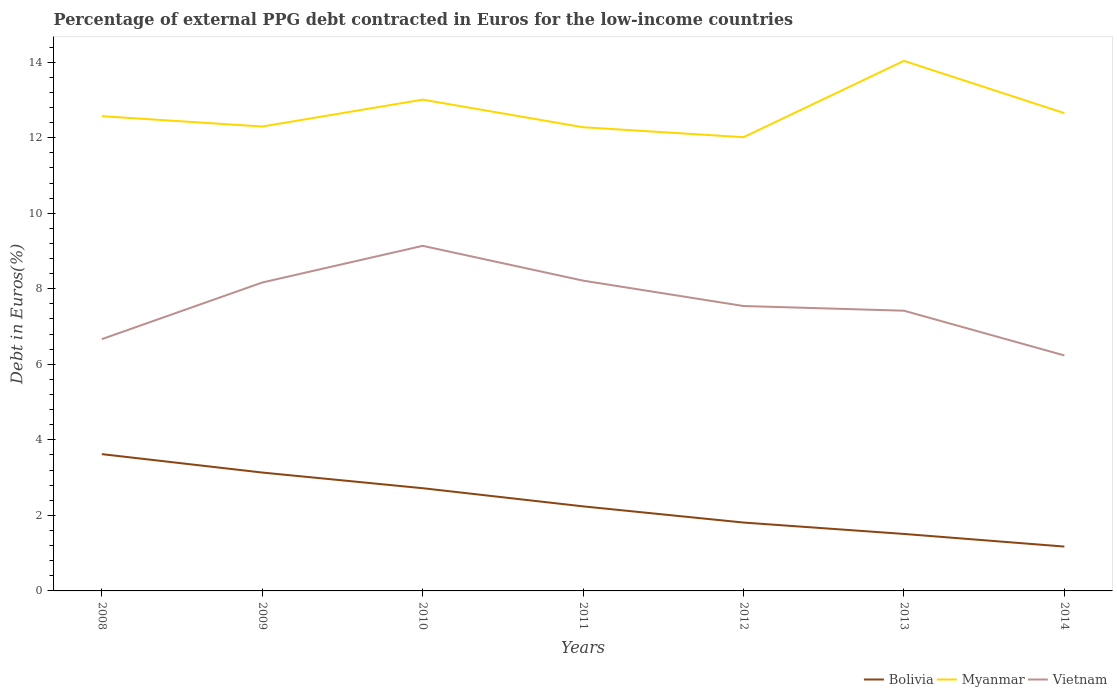Does the line corresponding to Bolivia intersect with the line corresponding to Vietnam?
Your answer should be compact. No. Is the number of lines equal to the number of legend labels?
Offer a very short reply. Yes. Across all years, what is the maximum percentage of external PPG debt contracted in Euros in Myanmar?
Ensure brevity in your answer.  12.01. In which year was the percentage of external PPG debt contracted in Euros in Myanmar maximum?
Give a very brief answer. 2012. What is the total percentage of external PPG debt contracted in Euros in Bolivia in the graph?
Make the answer very short. 1.63. What is the difference between the highest and the second highest percentage of external PPG debt contracted in Euros in Vietnam?
Give a very brief answer. 2.9. What is the difference between the highest and the lowest percentage of external PPG debt contracted in Euros in Myanmar?
Offer a very short reply. 2. Is the percentage of external PPG debt contracted in Euros in Myanmar strictly greater than the percentage of external PPG debt contracted in Euros in Bolivia over the years?
Ensure brevity in your answer.  No. How many years are there in the graph?
Give a very brief answer. 7. What is the difference between two consecutive major ticks on the Y-axis?
Make the answer very short. 2. Are the values on the major ticks of Y-axis written in scientific E-notation?
Ensure brevity in your answer.  No. Does the graph contain any zero values?
Your response must be concise. No. Does the graph contain grids?
Your answer should be very brief. No. Where does the legend appear in the graph?
Your answer should be compact. Bottom right. How many legend labels are there?
Provide a succinct answer. 3. How are the legend labels stacked?
Give a very brief answer. Horizontal. What is the title of the graph?
Keep it short and to the point. Percentage of external PPG debt contracted in Euros for the low-income countries. Does "Kenya" appear as one of the legend labels in the graph?
Ensure brevity in your answer.  No. What is the label or title of the X-axis?
Your answer should be compact. Years. What is the label or title of the Y-axis?
Make the answer very short. Debt in Euros(%). What is the Debt in Euros(%) of Bolivia in 2008?
Ensure brevity in your answer.  3.62. What is the Debt in Euros(%) of Myanmar in 2008?
Your response must be concise. 12.57. What is the Debt in Euros(%) in Vietnam in 2008?
Keep it short and to the point. 6.67. What is the Debt in Euros(%) of Bolivia in 2009?
Provide a short and direct response. 3.13. What is the Debt in Euros(%) in Myanmar in 2009?
Provide a succinct answer. 12.3. What is the Debt in Euros(%) in Vietnam in 2009?
Offer a terse response. 8.17. What is the Debt in Euros(%) in Bolivia in 2010?
Your response must be concise. 2.72. What is the Debt in Euros(%) of Myanmar in 2010?
Make the answer very short. 13.01. What is the Debt in Euros(%) of Vietnam in 2010?
Offer a terse response. 9.14. What is the Debt in Euros(%) in Bolivia in 2011?
Your answer should be very brief. 2.24. What is the Debt in Euros(%) of Myanmar in 2011?
Offer a very short reply. 12.28. What is the Debt in Euros(%) in Vietnam in 2011?
Give a very brief answer. 8.22. What is the Debt in Euros(%) of Bolivia in 2012?
Your response must be concise. 1.81. What is the Debt in Euros(%) in Myanmar in 2012?
Make the answer very short. 12.01. What is the Debt in Euros(%) in Vietnam in 2012?
Offer a terse response. 7.54. What is the Debt in Euros(%) of Bolivia in 2013?
Give a very brief answer. 1.51. What is the Debt in Euros(%) of Myanmar in 2013?
Your response must be concise. 14.03. What is the Debt in Euros(%) of Vietnam in 2013?
Make the answer very short. 7.42. What is the Debt in Euros(%) of Bolivia in 2014?
Your answer should be very brief. 1.17. What is the Debt in Euros(%) in Myanmar in 2014?
Provide a short and direct response. 12.65. What is the Debt in Euros(%) in Vietnam in 2014?
Ensure brevity in your answer.  6.23. Across all years, what is the maximum Debt in Euros(%) of Bolivia?
Provide a succinct answer. 3.62. Across all years, what is the maximum Debt in Euros(%) in Myanmar?
Keep it short and to the point. 14.03. Across all years, what is the maximum Debt in Euros(%) in Vietnam?
Make the answer very short. 9.14. Across all years, what is the minimum Debt in Euros(%) of Bolivia?
Make the answer very short. 1.17. Across all years, what is the minimum Debt in Euros(%) of Myanmar?
Provide a short and direct response. 12.01. Across all years, what is the minimum Debt in Euros(%) of Vietnam?
Provide a succinct answer. 6.23. What is the total Debt in Euros(%) in Bolivia in the graph?
Provide a short and direct response. 16.21. What is the total Debt in Euros(%) of Myanmar in the graph?
Provide a succinct answer. 88.85. What is the total Debt in Euros(%) of Vietnam in the graph?
Your answer should be compact. 53.38. What is the difference between the Debt in Euros(%) of Bolivia in 2008 and that in 2009?
Provide a short and direct response. 0.49. What is the difference between the Debt in Euros(%) of Myanmar in 2008 and that in 2009?
Provide a succinct answer. 0.27. What is the difference between the Debt in Euros(%) in Vietnam in 2008 and that in 2009?
Your answer should be very brief. -1.5. What is the difference between the Debt in Euros(%) in Bolivia in 2008 and that in 2010?
Offer a terse response. 0.9. What is the difference between the Debt in Euros(%) of Myanmar in 2008 and that in 2010?
Offer a very short reply. -0.44. What is the difference between the Debt in Euros(%) of Vietnam in 2008 and that in 2010?
Offer a terse response. -2.47. What is the difference between the Debt in Euros(%) in Bolivia in 2008 and that in 2011?
Ensure brevity in your answer.  1.38. What is the difference between the Debt in Euros(%) in Myanmar in 2008 and that in 2011?
Offer a very short reply. 0.29. What is the difference between the Debt in Euros(%) of Vietnam in 2008 and that in 2011?
Make the answer very short. -1.55. What is the difference between the Debt in Euros(%) in Bolivia in 2008 and that in 2012?
Your answer should be compact. 1.81. What is the difference between the Debt in Euros(%) in Myanmar in 2008 and that in 2012?
Offer a very short reply. 0.56. What is the difference between the Debt in Euros(%) in Vietnam in 2008 and that in 2012?
Your response must be concise. -0.88. What is the difference between the Debt in Euros(%) in Bolivia in 2008 and that in 2013?
Your response must be concise. 2.11. What is the difference between the Debt in Euros(%) of Myanmar in 2008 and that in 2013?
Provide a short and direct response. -1.46. What is the difference between the Debt in Euros(%) in Vietnam in 2008 and that in 2013?
Keep it short and to the point. -0.75. What is the difference between the Debt in Euros(%) of Bolivia in 2008 and that in 2014?
Give a very brief answer. 2.45. What is the difference between the Debt in Euros(%) of Myanmar in 2008 and that in 2014?
Give a very brief answer. -0.08. What is the difference between the Debt in Euros(%) of Vietnam in 2008 and that in 2014?
Your answer should be very brief. 0.43. What is the difference between the Debt in Euros(%) in Bolivia in 2009 and that in 2010?
Make the answer very short. 0.41. What is the difference between the Debt in Euros(%) of Myanmar in 2009 and that in 2010?
Offer a very short reply. -0.71. What is the difference between the Debt in Euros(%) of Vietnam in 2009 and that in 2010?
Give a very brief answer. -0.97. What is the difference between the Debt in Euros(%) in Bolivia in 2009 and that in 2011?
Ensure brevity in your answer.  0.9. What is the difference between the Debt in Euros(%) of Myanmar in 2009 and that in 2011?
Make the answer very short. 0.02. What is the difference between the Debt in Euros(%) in Vietnam in 2009 and that in 2011?
Your answer should be compact. -0.05. What is the difference between the Debt in Euros(%) of Bolivia in 2009 and that in 2012?
Your answer should be compact. 1.32. What is the difference between the Debt in Euros(%) of Myanmar in 2009 and that in 2012?
Offer a terse response. 0.28. What is the difference between the Debt in Euros(%) of Vietnam in 2009 and that in 2012?
Offer a very short reply. 0.62. What is the difference between the Debt in Euros(%) of Bolivia in 2009 and that in 2013?
Ensure brevity in your answer.  1.63. What is the difference between the Debt in Euros(%) in Myanmar in 2009 and that in 2013?
Your answer should be compact. -1.74. What is the difference between the Debt in Euros(%) in Vietnam in 2009 and that in 2013?
Give a very brief answer. 0.75. What is the difference between the Debt in Euros(%) of Bolivia in 2009 and that in 2014?
Ensure brevity in your answer.  1.96. What is the difference between the Debt in Euros(%) of Myanmar in 2009 and that in 2014?
Give a very brief answer. -0.35. What is the difference between the Debt in Euros(%) in Vietnam in 2009 and that in 2014?
Ensure brevity in your answer.  1.93. What is the difference between the Debt in Euros(%) in Bolivia in 2010 and that in 2011?
Your response must be concise. 0.48. What is the difference between the Debt in Euros(%) of Myanmar in 2010 and that in 2011?
Keep it short and to the point. 0.73. What is the difference between the Debt in Euros(%) of Vietnam in 2010 and that in 2011?
Offer a very short reply. 0.92. What is the difference between the Debt in Euros(%) of Bolivia in 2010 and that in 2012?
Offer a very short reply. 0.91. What is the difference between the Debt in Euros(%) in Myanmar in 2010 and that in 2012?
Make the answer very short. 0.99. What is the difference between the Debt in Euros(%) in Vietnam in 2010 and that in 2012?
Ensure brevity in your answer.  1.59. What is the difference between the Debt in Euros(%) in Bolivia in 2010 and that in 2013?
Offer a terse response. 1.21. What is the difference between the Debt in Euros(%) of Myanmar in 2010 and that in 2013?
Your answer should be compact. -1.03. What is the difference between the Debt in Euros(%) of Vietnam in 2010 and that in 2013?
Your answer should be very brief. 1.72. What is the difference between the Debt in Euros(%) of Bolivia in 2010 and that in 2014?
Provide a succinct answer. 1.54. What is the difference between the Debt in Euros(%) of Myanmar in 2010 and that in 2014?
Offer a very short reply. 0.36. What is the difference between the Debt in Euros(%) in Vietnam in 2010 and that in 2014?
Your response must be concise. 2.9. What is the difference between the Debt in Euros(%) of Bolivia in 2011 and that in 2012?
Keep it short and to the point. 0.43. What is the difference between the Debt in Euros(%) of Myanmar in 2011 and that in 2012?
Provide a short and direct response. 0.26. What is the difference between the Debt in Euros(%) in Vietnam in 2011 and that in 2012?
Ensure brevity in your answer.  0.67. What is the difference between the Debt in Euros(%) of Bolivia in 2011 and that in 2013?
Provide a succinct answer. 0.73. What is the difference between the Debt in Euros(%) in Myanmar in 2011 and that in 2013?
Your answer should be compact. -1.76. What is the difference between the Debt in Euros(%) in Vietnam in 2011 and that in 2013?
Make the answer very short. 0.8. What is the difference between the Debt in Euros(%) of Bolivia in 2011 and that in 2014?
Your answer should be compact. 1.06. What is the difference between the Debt in Euros(%) of Myanmar in 2011 and that in 2014?
Make the answer very short. -0.37. What is the difference between the Debt in Euros(%) of Vietnam in 2011 and that in 2014?
Make the answer very short. 1.98. What is the difference between the Debt in Euros(%) in Bolivia in 2012 and that in 2013?
Your answer should be compact. 0.3. What is the difference between the Debt in Euros(%) in Myanmar in 2012 and that in 2013?
Offer a very short reply. -2.02. What is the difference between the Debt in Euros(%) of Vietnam in 2012 and that in 2013?
Keep it short and to the point. 0.12. What is the difference between the Debt in Euros(%) of Bolivia in 2012 and that in 2014?
Offer a terse response. 0.64. What is the difference between the Debt in Euros(%) of Myanmar in 2012 and that in 2014?
Offer a terse response. -0.64. What is the difference between the Debt in Euros(%) in Vietnam in 2012 and that in 2014?
Offer a terse response. 1.31. What is the difference between the Debt in Euros(%) in Bolivia in 2013 and that in 2014?
Your response must be concise. 0.33. What is the difference between the Debt in Euros(%) in Myanmar in 2013 and that in 2014?
Ensure brevity in your answer.  1.38. What is the difference between the Debt in Euros(%) of Vietnam in 2013 and that in 2014?
Offer a very short reply. 1.18. What is the difference between the Debt in Euros(%) in Bolivia in 2008 and the Debt in Euros(%) in Myanmar in 2009?
Ensure brevity in your answer.  -8.67. What is the difference between the Debt in Euros(%) in Bolivia in 2008 and the Debt in Euros(%) in Vietnam in 2009?
Keep it short and to the point. -4.54. What is the difference between the Debt in Euros(%) of Myanmar in 2008 and the Debt in Euros(%) of Vietnam in 2009?
Make the answer very short. 4.4. What is the difference between the Debt in Euros(%) in Bolivia in 2008 and the Debt in Euros(%) in Myanmar in 2010?
Give a very brief answer. -9.39. What is the difference between the Debt in Euros(%) of Bolivia in 2008 and the Debt in Euros(%) of Vietnam in 2010?
Ensure brevity in your answer.  -5.51. What is the difference between the Debt in Euros(%) of Myanmar in 2008 and the Debt in Euros(%) of Vietnam in 2010?
Your response must be concise. 3.43. What is the difference between the Debt in Euros(%) of Bolivia in 2008 and the Debt in Euros(%) of Myanmar in 2011?
Give a very brief answer. -8.65. What is the difference between the Debt in Euros(%) in Bolivia in 2008 and the Debt in Euros(%) in Vietnam in 2011?
Your response must be concise. -4.59. What is the difference between the Debt in Euros(%) in Myanmar in 2008 and the Debt in Euros(%) in Vietnam in 2011?
Keep it short and to the point. 4.35. What is the difference between the Debt in Euros(%) in Bolivia in 2008 and the Debt in Euros(%) in Myanmar in 2012?
Your answer should be compact. -8.39. What is the difference between the Debt in Euros(%) in Bolivia in 2008 and the Debt in Euros(%) in Vietnam in 2012?
Give a very brief answer. -3.92. What is the difference between the Debt in Euros(%) in Myanmar in 2008 and the Debt in Euros(%) in Vietnam in 2012?
Ensure brevity in your answer.  5.03. What is the difference between the Debt in Euros(%) of Bolivia in 2008 and the Debt in Euros(%) of Myanmar in 2013?
Give a very brief answer. -10.41. What is the difference between the Debt in Euros(%) in Bolivia in 2008 and the Debt in Euros(%) in Vietnam in 2013?
Provide a short and direct response. -3.8. What is the difference between the Debt in Euros(%) in Myanmar in 2008 and the Debt in Euros(%) in Vietnam in 2013?
Provide a short and direct response. 5.15. What is the difference between the Debt in Euros(%) in Bolivia in 2008 and the Debt in Euros(%) in Myanmar in 2014?
Offer a very short reply. -9.03. What is the difference between the Debt in Euros(%) of Bolivia in 2008 and the Debt in Euros(%) of Vietnam in 2014?
Your answer should be compact. -2.61. What is the difference between the Debt in Euros(%) in Myanmar in 2008 and the Debt in Euros(%) in Vietnam in 2014?
Your answer should be very brief. 6.34. What is the difference between the Debt in Euros(%) of Bolivia in 2009 and the Debt in Euros(%) of Myanmar in 2010?
Make the answer very short. -9.87. What is the difference between the Debt in Euros(%) of Bolivia in 2009 and the Debt in Euros(%) of Vietnam in 2010?
Your response must be concise. -6. What is the difference between the Debt in Euros(%) of Myanmar in 2009 and the Debt in Euros(%) of Vietnam in 2010?
Provide a short and direct response. 3.16. What is the difference between the Debt in Euros(%) in Bolivia in 2009 and the Debt in Euros(%) in Myanmar in 2011?
Your response must be concise. -9.14. What is the difference between the Debt in Euros(%) of Bolivia in 2009 and the Debt in Euros(%) of Vietnam in 2011?
Ensure brevity in your answer.  -5.08. What is the difference between the Debt in Euros(%) in Myanmar in 2009 and the Debt in Euros(%) in Vietnam in 2011?
Offer a very short reply. 4.08. What is the difference between the Debt in Euros(%) of Bolivia in 2009 and the Debt in Euros(%) of Myanmar in 2012?
Give a very brief answer. -8.88. What is the difference between the Debt in Euros(%) of Bolivia in 2009 and the Debt in Euros(%) of Vietnam in 2012?
Give a very brief answer. -4.41. What is the difference between the Debt in Euros(%) of Myanmar in 2009 and the Debt in Euros(%) of Vietnam in 2012?
Offer a terse response. 4.75. What is the difference between the Debt in Euros(%) in Bolivia in 2009 and the Debt in Euros(%) in Myanmar in 2013?
Make the answer very short. -10.9. What is the difference between the Debt in Euros(%) in Bolivia in 2009 and the Debt in Euros(%) in Vietnam in 2013?
Your answer should be compact. -4.29. What is the difference between the Debt in Euros(%) of Myanmar in 2009 and the Debt in Euros(%) of Vietnam in 2013?
Keep it short and to the point. 4.88. What is the difference between the Debt in Euros(%) of Bolivia in 2009 and the Debt in Euros(%) of Myanmar in 2014?
Make the answer very short. -9.52. What is the difference between the Debt in Euros(%) in Bolivia in 2009 and the Debt in Euros(%) in Vietnam in 2014?
Offer a very short reply. -3.1. What is the difference between the Debt in Euros(%) in Myanmar in 2009 and the Debt in Euros(%) in Vietnam in 2014?
Your answer should be compact. 6.06. What is the difference between the Debt in Euros(%) of Bolivia in 2010 and the Debt in Euros(%) of Myanmar in 2011?
Give a very brief answer. -9.56. What is the difference between the Debt in Euros(%) in Bolivia in 2010 and the Debt in Euros(%) in Vietnam in 2011?
Give a very brief answer. -5.5. What is the difference between the Debt in Euros(%) of Myanmar in 2010 and the Debt in Euros(%) of Vietnam in 2011?
Provide a short and direct response. 4.79. What is the difference between the Debt in Euros(%) of Bolivia in 2010 and the Debt in Euros(%) of Myanmar in 2012?
Give a very brief answer. -9.29. What is the difference between the Debt in Euros(%) of Bolivia in 2010 and the Debt in Euros(%) of Vietnam in 2012?
Offer a very short reply. -4.82. What is the difference between the Debt in Euros(%) of Myanmar in 2010 and the Debt in Euros(%) of Vietnam in 2012?
Your response must be concise. 5.46. What is the difference between the Debt in Euros(%) in Bolivia in 2010 and the Debt in Euros(%) in Myanmar in 2013?
Offer a very short reply. -11.32. What is the difference between the Debt in Euros(%) of Bolivia in 2010 and the Debt in Euros(%) of Vietnam in 2013?
Provide a succinct answer. -4.7. What is the difference between the Debt in Euros(%) in Myanmar in 2010 and the Debt in Euros(%) in Vietnam in 2013?
Offer a terse response. 5.59. What is the difference between the Debt in Euros(%) in Bolivia in 2010 and the Debt in Euros(%) in Myanmar in 2014?
Ensure brevity in your answer.  -9.93. What is the difference between the Debt in Euros(%) of Bolivia in 2010 and the Debt in Euros(%) of Vietnam in 2014?
Make the answer very short. -3.52. What is the difference between the Debt in Euros(%) in Myanmar in 2010 and the Debt in Euros(%) in Vietnam in 2014?
Give a very brief answer. 6.77. What is the difference between the Debt in Euros(%) in Bolivia in 2011 and the Debt in Euros(%) in Myanmar in 2012?
Keep it short and to the point. -9.77. What is the difference between the Debt in Euros(%) of Bolivia in 2011 and the Debt in Euros(%) of Vietnam in 2012?
Keep it short and to the point. -5.3. What is the difference between the Debt in Euros(%) of Myanmar in 2011 and the Debt in Euros(%) of Vietnam in 2012?
Your answer should be very brief. 4.73. What is the difference between the Debt in Euros(%) of Bolivia in 2011 and the Debt in Euros(%) of Myanmar in 2013?
Make the answer very short. -11.8. What is the difference between the Debt in Euros(%) of Bolivia in 2011 and the Debt in Euros(%) of Vietnam in 2013?
Offer a very short reply. -5.18. What is the difference between the Debt in Euros(%) of Myanmar in 2011 and the Debt in Euros(%) of Vietnam in 2013?
Provide a succinct answer. 4.86. What is the difference between the Debt in Euros(%) of Bolivia in 2011 and the Debt in Euros(%) of Myanmar in 2014?
Give a very brief answer. -10.41. What is the difference between the Debt in Euros(%) of Bolivia in 2011 and the Debt in Euros(%) of Vietnam in 2014?
Offer a terse response. -4. What is the difference between the Debt in Euros(%) in Myanmar in 2011 and the Debt in Euros(%) in Vietnam in 2014?
Your answer should be compact. 6.04. What is the difference between the Debt in Euros(%) of Bolivia in 2012 and the Debt in Euros(%) of Myanmar in 2013?
Your answer should be very brief. -12.22. What is the difference between the Debt in Euros(%) of Bolivia in 2012 and the Debt in Euros(%) of Vietnam in 2013?
Offer a very short reply. -5.61. What is the difference between the Debt in Euros(%) in Myanmar in 2012 and the Debt in Euros(%) in Vietnam in 2013?
Keep it short and to the point. 4.59. What is the difference between the Debt in Euros(%) in Bolivia in 2012 and the Debt in Euros(%) in Myanmar in 2014?
Provide a short and direct response. -10.84. What is the difference between the Debt in Euros(%) of Bolivia in 2012 and the Debt in Euros(%) of Vietnam in 2014?
Keep it short and to the point. -4.42. What is the difference between the Debt in Euros(%) of Myanmar in 2012 and the Debt in Euros(%) of Vietnam in 2014?
Offer a terse response. 5.78. What is the difference between the Debt in Euros(%) in Bolivia in 2013 and the Debt in Euros(%) in Myanmar in 2014?
Give a very brief answer. -11.14. What is the difference between the Debt in Euros(%) in Bolivia in 2013 and the Debt in Euros(%) in Vietnam in 2014?
Ensure brevity in your answer.  -4.73. What is the difference between the Debt in Euros(%) in Myanmar in 2013 and the Debt in Euros(%) in Vietnam in 2014?
Ensure brevity in your answer.  7.8. What is the average Debt in Euros(%) in Bolivia per year?
Your answer should be very brief. 2.32. What is the average Debt in Euros(%) in Myanmar per year?
Your response must be concise. 12.69. What is the average Debt in Euros(%) of Vietnam per year?
Your answer should be very brief. 7.63. In the year 2008, what is the difference between the Debt in Euros(%) of Bolivia and Debt in Euros(%) of Myanmar?
Offer a terse response. -8.95. In the year 2008, what is the difference between the Debt in Euros(%) of Bolivia and Debt in Euros(%) of Vietnam?
Provide a short and direct response. -3.04. In the year 2008, what is the difference between the Debt in Euros(%) in Myanmar and Debt in Euros(%) in Vietnam?
Your response must be concise. 5.9. In the year 2009, what is the difference between the Debt in Euros(%) in Bolivia and Debt in Euros(%) in Myanmar?
Offer a terse response. -9.16. In the year 2009, what is the difference between the Debt in Euros(%) in Bolivia and Debt in Euros(%) in Vietnam?
Keep it short and to the point. -5.03. In the year 2009, what is the difference between the Debt in Euros(%) of Myanmar and Debt in Euros(%) of Vietnam?
Your response must be concise. 4.13. In the year 2010, what is the difference between the Debt in Euros(%) in Bolivia and Debt in Euros(%) in Myanmar?
Provide a short and direct response. -10.29. In the year 2010, what is the difference between the Debt in Euros(%) of Bolivia and Debt in Euros(%) of Vietnam?
Your response must be concise. -6.42. In the year 2010, what is the difference between the Debt in Euros(%) of Myanmar and Debt in Euros(%) of Vietnam?
Your answer should be very brief. 3.87. In the year 2011, what is the difference between the Debt in Euros(%) of Bolivia and Debt in Euros(%) of Myanmar?
Your answer should be compact. -10.04. In the year 2011, what is the difference between the Debt in Euros(%) in Bolivia and Debt in Euros(%) in Vietnam?
Your response must be concise. -5.98. In the year 2011, what is the difference between the Debt in Euros(%) in Myanmar and Debt in Euros(%) in Vietnam?
Your response must be concise. 4.06. In the year 2012, what is the difference between the Debt in Euros(%) in Bolivia and Debt in Euros(%) in Myanmar?
Make the answer very short. -10.2. In the year 2012, what is the difference between the Debt in Euros(%) of Bolivia and Debt in Euros(%) of Vietnam?
Offer a terse response. -5.73. In the year 2012, what is the difference between the Debt in Euros(%) in Myanmar and Debt in Euros(%) in Vietnam?
Keep it short and to the point. 4.47. In the year 2013, what is the difference between the Debt in Euros(%) in Bolivia and Debt in Euros(%) in Myanmar?
Ensure brevity in your answer.  -12.53. In the year 2013, what is the difference between the Debt in Euros(%) in Bolivia and Debt in Euros(%) in Vietnam?
Offer a very short reply. -5.91. In the year 2013, what is the difference between the Debt in Euros(%) in Myanmar and Debt in Euros(%) in Vietnam?
Provide a short and direct response. 6.62. In the year 2014, what is the difference between the Debt in Euros(%) in Bolivia and Debt in Euros(%) in Myanmar?
Give a very brief answer. -11.48. In the year 2014, what is the difference between the Debt in Euros(%) of Bolivia and Debt in Euros(%) of Vietnam?
Give a very brief answer. -5.06. In the year 2014, what is the difference between the Debt in Euros(%) of Myanmar and Debt in Euros(%) of Vietnam?
Provide a short and direct response. 6.42. What is the ratio of the Debt in Euros(%) of Bolivia in 2008 to that in 2009?
Your response must be concise. 1.16. What is the ratio of the Debt in Euros(%) in Myanmar in 2008 to that in 2009?
Ensure brevity in your answer.  1.02. What is the ratio of the Debt in Euros(%) of Vietnam in 2008 to that in 2009?
Your answer should be very brief. 0.82. What is the ratio of the Debt in Euros(%) in Bolivia in 2008 to that in 2010?
Your response must be concise. 1.33. What is the ratio of the Debt in Euros(%) in Myanmar in 2008 to that in 2010?
Offer a terse response. 0.97. What is the ratio of the Debt in Euros(%) in Vietnam in 2008 to that in 2010?
Make the answer very short. 0.73. What is the ratio of the Debt in Euros(%) of Bolivia in 2008 to that in 2011?
Ensure brevity in your answer.  1.62. What is the ratio of the Debt in Euros(%) in Myanmar in 2008 to that in 2011?
Keep it short and to the point. 1.02. What is the ratio of the Debt in Euros(%) of Vietnam in 2008 to that in 2011?
Offer a terse response. 0.81. What is the ratio of the Debt in Euros(%) of Bolivia in 2008 to that in 2012?
Your answer should be compact. 2. What is the ratio of the Debt in Euros(%) in Myanmar in 2008 to that in 2012?
Ensure brevity in your answer.  1.05. What is the ratio of the Debt in Euros(%) of Vietnam in 2008 to that in 2012?
Offer a terse response. 0.88. What is the ratio of the Debt in Euros(%) of Bolivia in 2008 to that in 2013?
Your response must be concise. 2.4. What is the ratio of the Debt in Euros(%) in Myanmar in 2008 to that in 2013?
Provide a succinct answer. 0.9. What is the ratio of the Debt in Euros(%) of Vietnam in 2008 to that in 2013?
Give a very brief answer. 0.9. What is the ratio of the Debt in Euros(%) in Bolivia in 2008 to that in 2014?
Keep it short and to the point. 3.08. What is the ratio of the Debt in Euros(%) in Myanmar in 2008 to that in 2014?
Make the answer very short. 0.99. What is the ratio of the Debt in Euros(%) of Vietnam in 2008 to that in 2014?
Your response must be concise. 1.07. What is the ratio of the Debt in Euros(%) of Bolivia in 2009 to that in 2010?
Your response must be concise. 1.15. What is the ratio of the Debt in Euros(%) of Myanmar in 2009 to that in 2010?
Your answer should be very brief. 0.95. What is the ratio of the Debt in Euros(%) of Vietnam in 2009 to that in 2010?
Ensure brevity in your answer.  0.89. What is the ratio of the Debt in Euros(%) of Bolivia in 2009 to that in 2011?
Your answer should be very brief. 1.4. What is the ratio of the Debt in Euros(%) of Myanmar in 2009 to that in 2011?
Your answer should be compact. 1. What is the ratio of the Debt in Euros(%) in Vietnam in 2009 to that in 2011?
Make the answer very short. 0.99. What is the ratio of the Debt in Euros(%) of Bolivia in 2009 to that in 2012?
Ensure brevity in your answer.  1.73. What is the ratio of the Debt in Euros(%) in Myanmar in 2009 to that in 2012?
Your response must be concise. 1.02. What is the ratio of the Debt in Euros(%) of Vietnam in 2009 to that in 2012?
Offer a very short reply. 1.08. What is the ratio of the Debt in Euros(%) in Bolivia in 2009 to that in 2013?
Make the answer very short. 2.08. What is the ratio of the Debt in Euros(%) of Myanmar in 2009 to that in 2013?
Offer a very short reply. 0.88. What is the ratio of the Debt in Euros(%) of Vietnam in 2009 to that in 2013?
Give a very brief answer. 1.1. What is the ratio of the Debt in Euros(%) in Bolivia in 2009 to that in 2014?
Give a very brief answer. 2.67. What is the ratio of the Debt in Euros(%) of Myanmar in 2009 to that in 2014?
Provide a succinct answer. 0.97. What is the ratio of the Debt in Euros(%) in Vietnam in 2009 to that in 2014?
Offer a terse response. 1.31. What is the ratio of the Debt in Euros(%) in Bolivia in 2010 to that in 2011?
Provide a short and direct response. 1.21. What is the ratio of the Debt in Euros(%) in Myanmar in 2010 to that in 2011?
Offer a very short reply. 1.06. What is the ratio of the Debt in Euros(%) in Vietnam in 2010 to that in 2011?
Your answer should be very brief. 1.11. What is the ratio of the Debt in Euros(%) in Bolivia in 2010 to that in 2012?
Your answer should be very brief. 1.5. What is the ratio of the Debt in Euros(%) in Myanmar in 2010 to that in 2012?
Provide a short and direct response. 1.08. What is the ratio of the Debt in Euros(%) in Vietnam in 2010 to that in 2012?
Offer a terse response. 1.21. What is the ratio of the Debt in Euros(%) in Bolivia in 2010 to that in 2013?
Provide a short and direct response. 1.8. What is the ratio of the Debt in Euros(%) in Myanmar in 2010 to that in 2013?
Keep it short and to the point. 0.93. What is the ratio of the Debt in Euros(%) of Vietnam in 2010 to that in 2013?
Keep it short and to the point. 1.23. What is the ratio of the Debt in Euros(%) in Bolivia in 2010 to that in 2014?
Make the answer very short. 2.32. What is the ratio of the Debt in Euros(%) in Myanmar in 2010 to that in 2014?
Keep it short and to the point. 1.03. What is the ratio of the Debt in Euros(%) of Vietnam in 2010 to that in 2014?
Provide a succinct answer. 1.47. What is the ratio of the Debt in Euros(%) of Bolivia in 2011 to that in 2012?
Ensure brevity in your answer.  1.24. What is the ratio of the Debt in Euros(%) in Myanmar in 2011 to that in 2012?
Provide a succinct answer. 1.02. What is the ratio of the Debt in Euros(%) of Vietnam in 2011 to that in 2012?
Give a very brief answer. 1.09. What is the ratio of the Debt in Euros(%) in Bolivia in 2011 to that in 2013?
Provide a short and direct response. 1.48. What is the ratio of the Debt in Euros(%) of Myanmar in 2011 to that in 2013?
Keep it short and to the point. 0.87. What is the ratio of the Debt in Euros(%) in Vietnam in 2011 to that in 2013?
Provide a short and direct response. 1.11. What is the ratio of the Debt in Euros(%) of Bolivia in 2011 to that in 2014?
Keep it short and to the point. 1.91. What is the ratio of the Debt in Euros(%) of Myanmar in 2011 to that in 2014?
Offer a very short reply. 0.97. What is the ratio of the Debt in Euros(%) in Vietnam in 2011 to that in 2014?
Give a very brief answer. 1.32. What is the ratio of the Debt in Euros(%) of Bolivia in 2012 to that in 2013?
Offer a very short reply. 1.2. What is the ratio of the Debt in Euros(%) in Myanmar in 2012 to that in 2013?
Offer a very short reply. 0.86. What is the ratio of the Debt in Euros(%) of Vietnam in 2012 to that in 2013?
Ensure brevity in your answer.  1.02. What is the ratio of the Debt in Euros(%) of Bolivia in 2012 to that in 2014?
Offer a terse response. 1.54. What is the ratio of the Debt in Euros(%) of Myanmar in 2012 to that in 2014?
Your response must be concise. 0.95. What is the ratio of the Debt in Euros(%) in Vietnam in 2012 to that in 2014?
Provide a short and direct response. 1.21. What is the ratio of the Debt in Euros(%) in Bolivia in 2013 to that in 2014?
Make the answer very short. 1.28. What is the ratio of the Debt in Euros(%) of Myanmar in 2013 to that in 2014?
Ensure brevity in your answer.  1.11. What is the ratio of the Debt in Euros(%) in Vietnam in 2013 to that in 2014?
Ensure brevity in your answer.  1.19. What is the difference between the highest and the second highest Debt in Euros(%) in Bolivia?
Offer a very short reply. 0.49. What is the difference between the highest and the second highest Debt in Euros(%) in Myanmar?
Keep it short and to the point. 1.03. What is the difference between the highest and the second highest Debt in Euros(%) in Vietnam?
Offer a very short reply. 0.92. What is the difference between the highest and the lowest Debt in Euros(%) in Bolivia?
Provide a succinct answer. 2.45. What is the difference between the highest and the lowest Debt in Euros(%) of Myanmar?
Your answer should be compact. 2.02. What is the difference between the highest and the lowest Debt in Euros(%) of Vietnam?
Your answer should be compact. 2.9. 